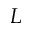<formula> <loc_0><loc_0><loc_500><loc_500>L</formula> 